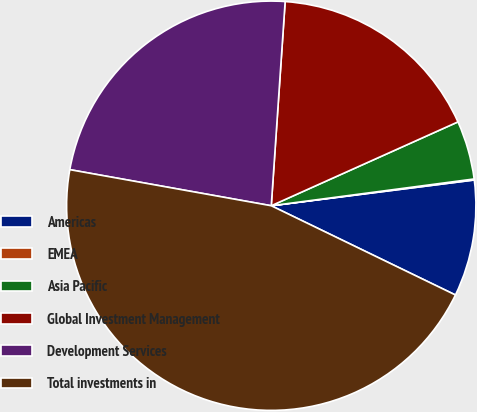<chart> <loc_0><loc_0><loc_500><loc_500><pie_chart><fcel>Americas<fcel>EMEA<fcel>Asia Pacific<fcel>Global Investment Management<fcel>Development Services<fcel>Total investments in<nl><fcel>9.19%<fcel>0.08%<fcel>4.63%<fcel>17.2%<fcel>23.26%<fcel>45.64%<nl></chart> 